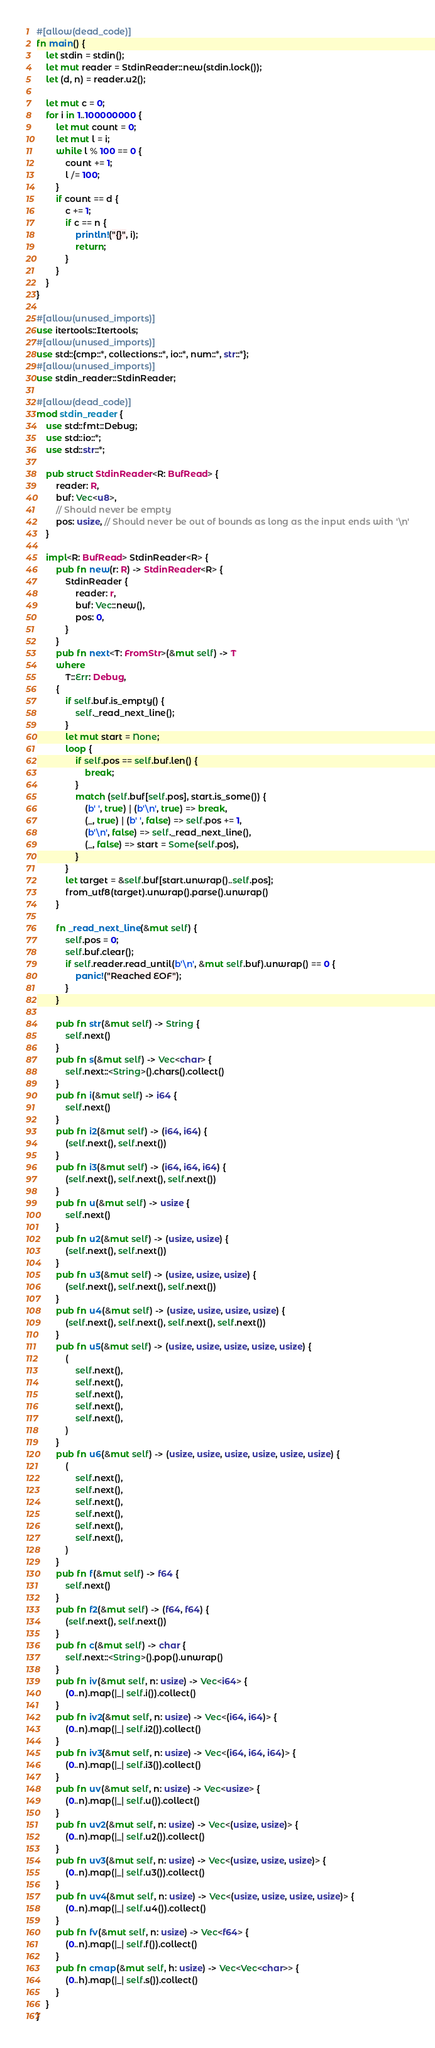Convert code to text. <code><loc_0><loc_0><loc_500><loc_500><_Rust_>#[allow(dead_code)]
fn main() {
    let stdin = stdin();
    let mut reader = StdinReader::new(stdin.lock());
    let (d, n) = reader.u2();

    let mut c = 0;
    for i in 1..100000000 {
        let mut count = 0;
        let mut l = i;
        while l % 100 == 0 {
            count += 1;
            l /= 100;
        }
        if count == d {
            c += 1;
            if c == n {
                println!("{}", i);
                return;
            }
        }
    }
}

#[allow(unused_imports)]
use itertools::Itertools;
#[allow(unused_imports)]
use std::{cmp::*, collections::*, io::*, num::*, str::*};
#[allow(unused_imports)]
use stdin_reader::StdinReader;

#[allow(dead_code)]
mod stdin_reader {
    use std::fmt::Debug;
    use std::io::*;
    use std::str::*;

    pub struct StdinReader<R: BufRead> {
        reader: R,
        buf: Vec<u8>,
        // Should never be empty
        pos: usize, // Should never be out of bounds as long as the input ends with '\n'
    }

    impl<R: BufRead> StdinReader<R> {
        pub fn new(r: R) -> StdinReader<R> {
            StdinReader {
                reader: r,
                buf: Vec::new(),
                pos: 0,
            }
        }
        pub fn next<T: FromStr>(&mut self) -> T
        where
            T::Err: Debug,
        {
            if self.buf.is_empty() {
                self._read_next_line();
            }
            let mut start = None;
            loop {
                if self.pos == self.buf.len() {
                    break;
                }
                match (self.buf[self.pos], start.is_some()) {
                    (b' ', true) | (b'\n', true) => break,
                    (_, true) | (b' ', false) => self.pos += 1,
                    (b'\n', false) => self._read_next_line(),
                    (_, false) => start = Some(self.pos),
                }
            }
            let target = &self.buf[start.unwrap()..self.pos];
            from_utf8(target).unwrap().parse().unwrap()
        }

        fn _read_next_line(&mut self) {
            self.pos = 0;
            self.buf.clear();
            if self.reader.read_until(b'\n', &mut self.buf).unwrap() == 0 {
                panic!("Reached EOF");
            }
        }

        pub fn str(&mut self) -> String {
            self.next()
        }
        pub fn s(&mut self) -> Vec<char> {
            self.next::<String>().chars().collect()
        }
        pub fn i(&mut self) -> i64 {
            self.next()
        }
        pub fn i2(&mut self) -> (i64, i64) {
            (self.next(), self.next())
        }
        pub fn i3(&mut self) -> (i64, i64, i64) {
            (self.next(), self.next(), self.next())
        }
        pub fn u(&mut self) -> usize {
            self.next()
        }
        pub fn u2(&mut self) -> (usize, usize) {
            (self.next(), self.next())
        }
        pub fn u3(&mut self) -> (usize, usize, usize) {
            (self.next(), self.next(), self.next())
        }
        pub fn u4(&mut self) -> (usize, usize, usize, usize) {
            (self.next(), self.next(), self.next(), self.next())
        }
        pub fn u5(&mut self) -> (usize, usize, usize, usize, usize) {
            (
                self.next(),
                self.next(),
                self.next(),
                self.next(),
                self.next(),
            )
        }
        pub fn u6(&mut self) -> (usize, usize, usize, usize, usize, usize) {
            (
                self.next(),
                self.next(),
                self.next(),
                self.next(),
                self.next(),
                self.next(),
            )
        }
        pub fn f(&mut self) -> f64 {
            self.next()
        }
        pub fn f2(&mut self) -> (f64, f64) {
            (self.next(), self.next())
        }
        pub fn c(&mut self) -> char {
            self.next::<String>().pop().unwrap()
        }
        pub fn iv(&mut self, n: usize) -> Vec<i64> {
            (0..n).map(|_| self.i()).collect()
        }
        pub fn iv2(&mut self, n: usize) -> Vec<(i64, i64)> {
            (0..n).map(|_| self.i2()).collect()
        }
        pub fn iv3(&mut self, n: usize) -> Vec<(i64, i64, i64)> {
            (0..n).map(|_| self.i3()).collect()
        }
        pub fn uv(&mut self, n: usize) -> Vec<usize> {
            (0..n).map(|_| self.u()).collect()
        }
        pub fn uv2(&mut self, n: usize) -> Vec<(usize, usize)> {
            (0..n).map(|_| self.u2()).collect()
        }
        pub fn uv3(&mut self, n: usize) -> Vec<(usize, usize, usize)> {
            (0..n).map(|_| self.u3()).collect()
        }
        pub fn uv4(&mut self, n: usize) -> Vec<(usize, usize, usize, usize)> {
            (0..n).map(|_| self.u4()).collect()
        }
        pub fn fv(&mut self, n: usize) -> Vec<f64> {
            (0..n).map(|_| self.f()).collect()
        }
        pub fn cmap(&mut self, h: usize) -> Vec<Vec<char>> {
            (0..h).map(|_| self.s()).collect()
        }
    }
}
</code> 